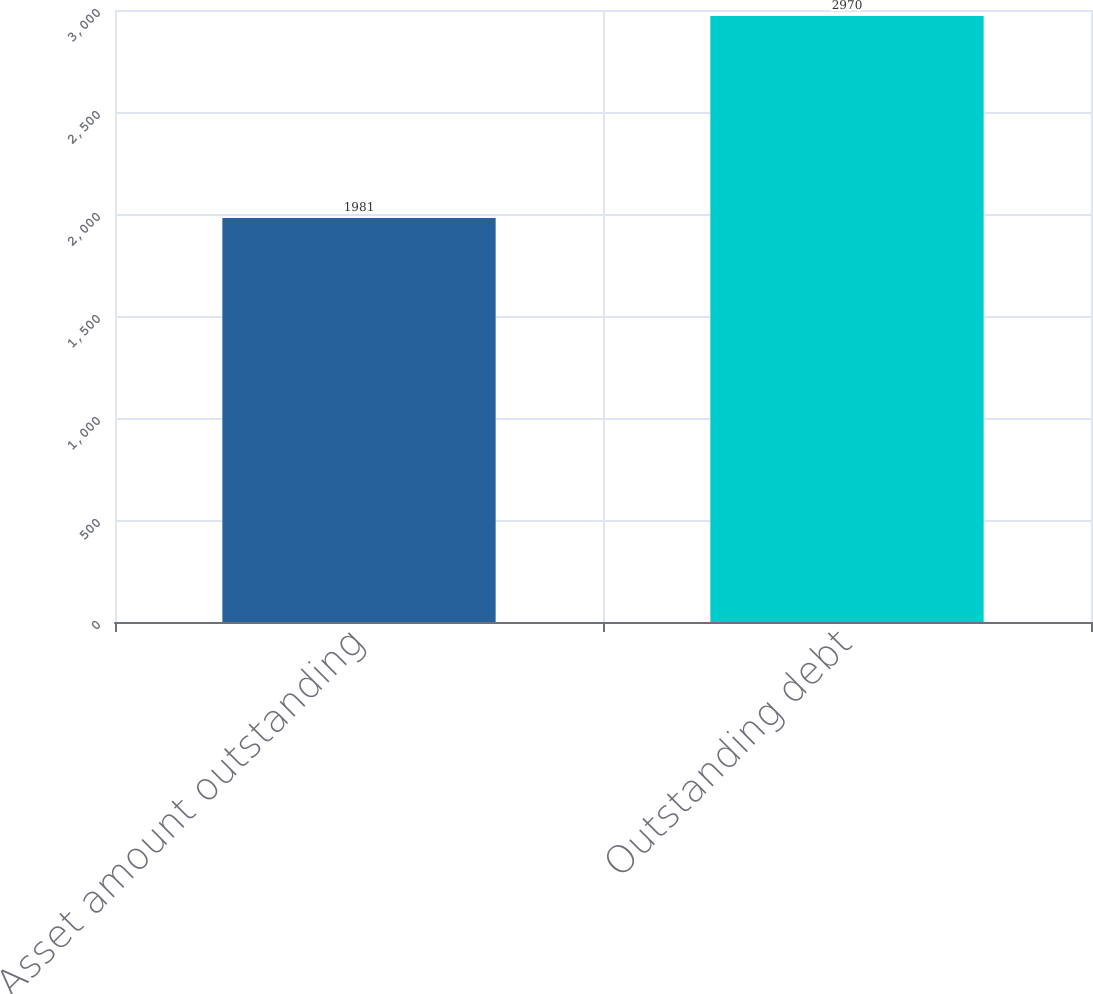Convert chart. <chart><loc_0><loc_0><loc_500><loc_500><bar_chart><fcel>Asset amount outstanding<fcel>Outstanding debt<nl><fcel>1981<fcel>2970<nl></chart> 